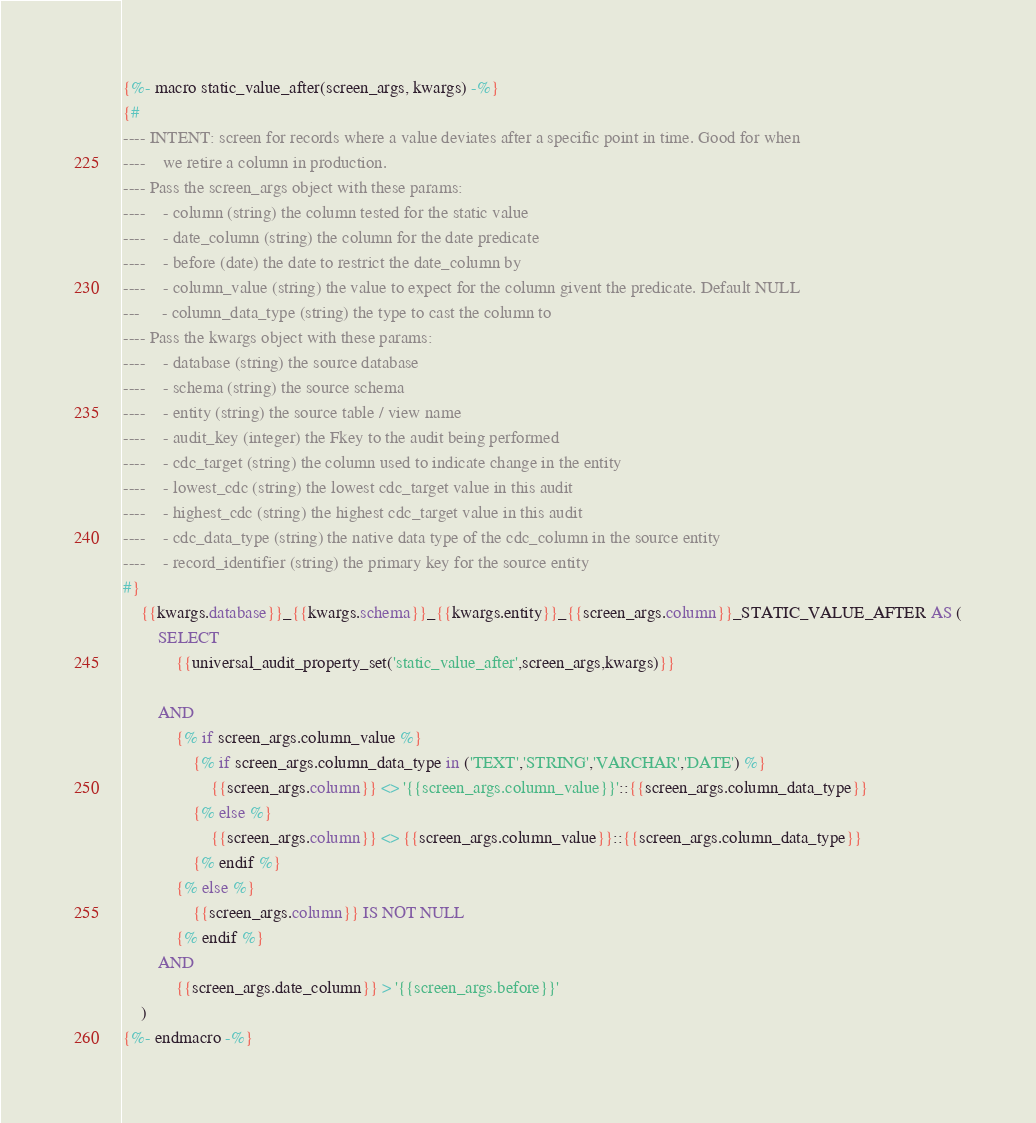<code> <loc_0><loc_0><loc_500><loc_500><_SQL_>
{%- macro static_value_after(screen_args, kwargs) -%}
{#
---- INTENT: screen for records where a value deviates after a specific point in time. Good for when 
----    we retire a column in production.
---- Pass the screen_args object with these params:
----    - column (string) the column tested for the static value
----    - date_column (string) the column for the date predicate
----    - before (date) the date to restrict the date_column by
----    - column_value (string) the value to expect for the column givent the predicate. Default NULL
---     - column_data_type (string) the type to cast the column to 
---- Pass the kwargs object with these params:
----    - database (string) the source database 
----    - schema (string) the source schema
----    - entity (string) the source table / view name
----    - audit_key (integer) the Fkey to the audit being performed
----    - cdc_target (string) the column used to indicate change in the entity
----    - lowest_cdc (string) the lowest cdc_target value in this audit
----    - highest_cdc (string) the highest cdc_target value in this audit
----    - cdc_data_type (string) the native data type of the cdc_column in the source entity
----    - record_identifier (string) the primary key for the source entity
#}
    {{kwargs.database}}_{{kwargs.schema}}_{{kwargs.entity}}_{{screen_args.column}}_STATIC_VALUE_AFTER AS (
        SELECT
            {{universal_audit_property_set('static_value_after',screen_args,kwargs)}}

        AND
            {% if screen_args.column_value %}
                {% if screen_args.column_data_type in ('TEXT','STRING','VARCHAR','DATE') %}
                    {{screen_args.column}} <> '{{screen_args.column_value}}'::{{screen_args.column_data_type}} 
                {% else %}
                    {{screen_args.column}} <> {{screen_args.column_value}}::{{screen_args.column_data_type}}
                {% endif %}
            {% else %}
                {{screen_args.column}} IS NOT NULL
            {% endif %}
        AND
            {{screen_args.date_column}} > '{{screen_args.before}}'
    )
{%- endmacro -%}
</code> 